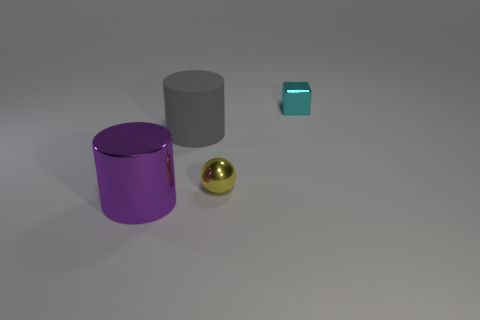What number of objects are both to the left of the small cyan shiny cube and behind the big purple cylinder?
Provide a succinct answer. 2. There is a cylinder that is right of the thing that is on the left side of the big matte object; what color is it?
Offer a terse response. Gray. Are there fewer large gray matte balls than gray matte objects?
Your answer should be very brief. Yes. Are there more big gray rubber things that are in front of the cyan object than big gray objects in front of the small yellow shiny ball?
Offer a very short reply. Yes. Are the cyan thing and the big purple object made of the same material?
Your response must be concise. Yes. How many small cyan metal blocks are behind the big object to the right of the purple thing?
Make the answer very short. 1. What number of objects are either tiny cyan blocks or objects that are behind the yellow thing?
Provide a short and direct response. 2. Do the small metal object to the left of the tiny cyan metal block and the big object right of the large purple metal thing have the same shape?
Make the answer very short. No. Is there any other thing that is the same color as the cube?
Give a very brief answer. No. The yellow object that is made of the same material as the cyan block is what shape?
Ensure brevity in your answer.  Sphere. 